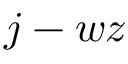Convert formula to latex. <formula><loc_0><loc_0><loc_500><loc_500>j - w z</formula> 